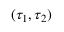<formula> <loc_0><loc_0><loc_500><loc_500>( \tau _ { 1 } , \tau _ { 2 } )</formula> 